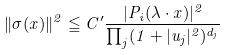Convert formula to latex. <formula><loc_0><loc_0><loc_500><loc_500>\| \sigma ( x ) \| ^ { 2 } \leqq C ^ { \prime } \frac { | P _ { i } ( \lambda \cdot x ) | ^ { 2 } } { \prod _ { j } ( 1 + | u _ { j } | ^ { 2 } ) ^ { d _ { j } } }</formula> 